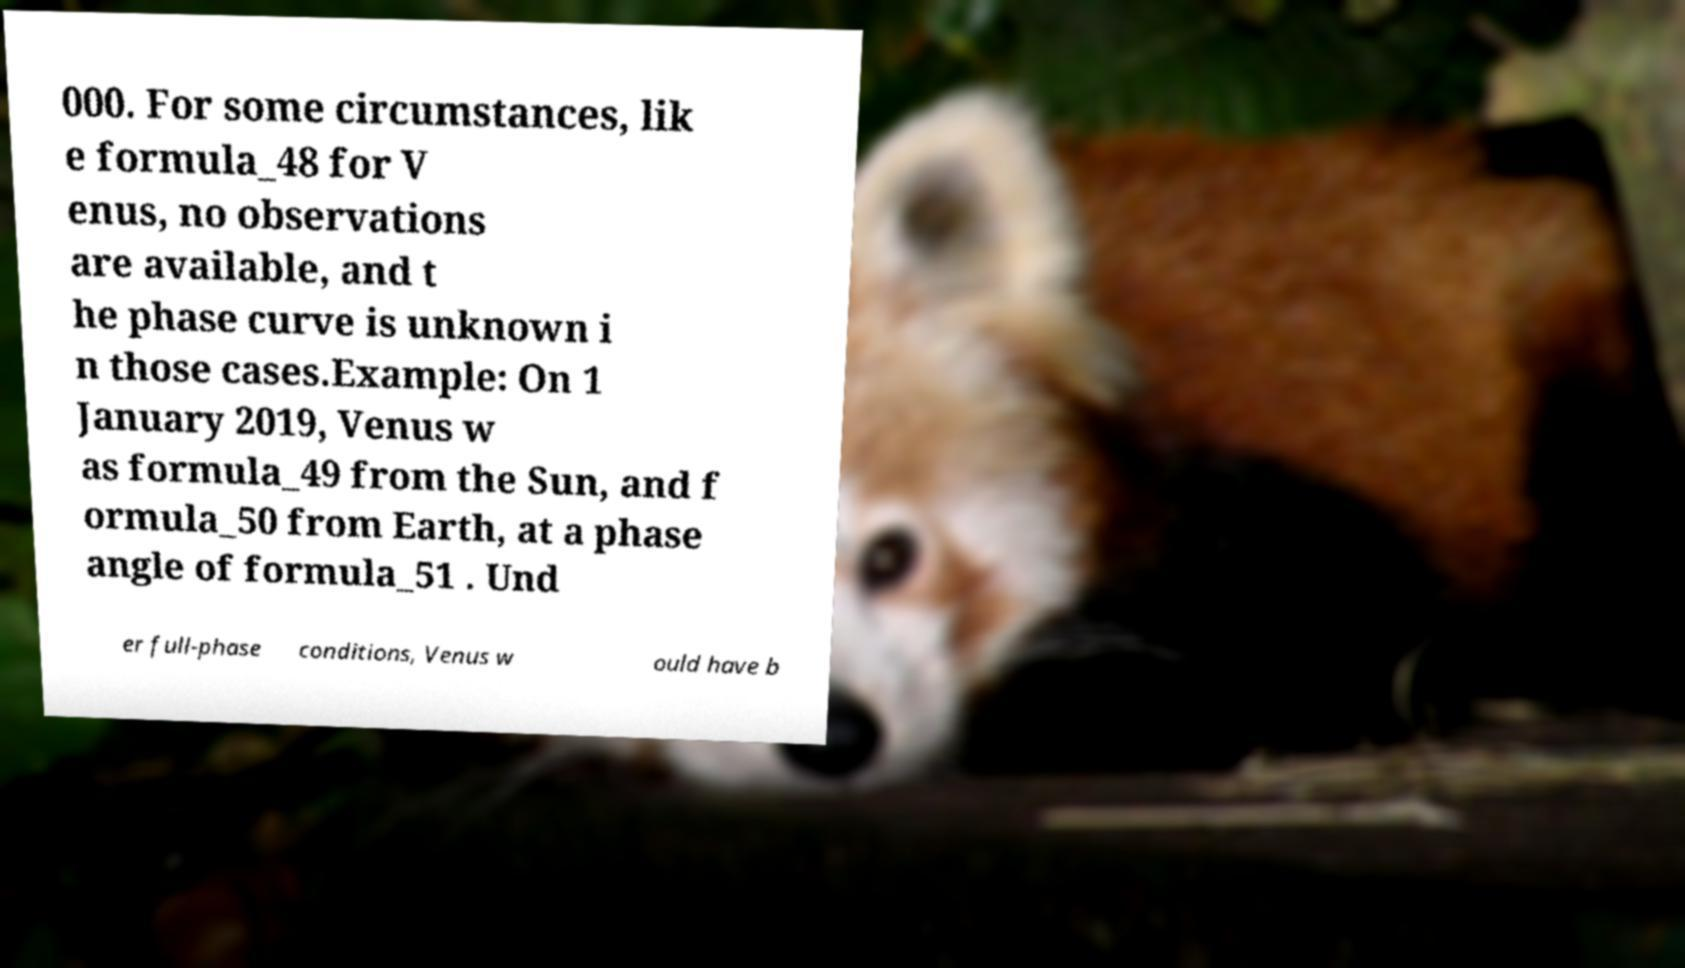For documentation purposes, I need the text within this image transcribed. Could you provide that? 000. For some circumstances, lik e formula_48 for V enus, no observations are available, and t he phase curve is unknown i n those cases.Example: On 1 January 2019, Venus w as formula_49 from the Sun, and f ormula_50 from Earth, at a phase angle of formula_51 . Und er full-phase conditions, Venus w ould have b 